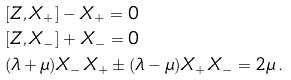Convert formula to latex. <formula><loc_0><loc_0><loc_500><loc_500>& [ Z , X _ { + } ] - X _ { + } = 0 \\ & [ Z , X _ { - } ] + X _ { - } = 0 \\ & ( \lambda + \mu ) X _ { - } X _ { + } \pm ( \lambda - \mu ) X _ { + } X _ { - } = 2 \mu \, .</formula> 